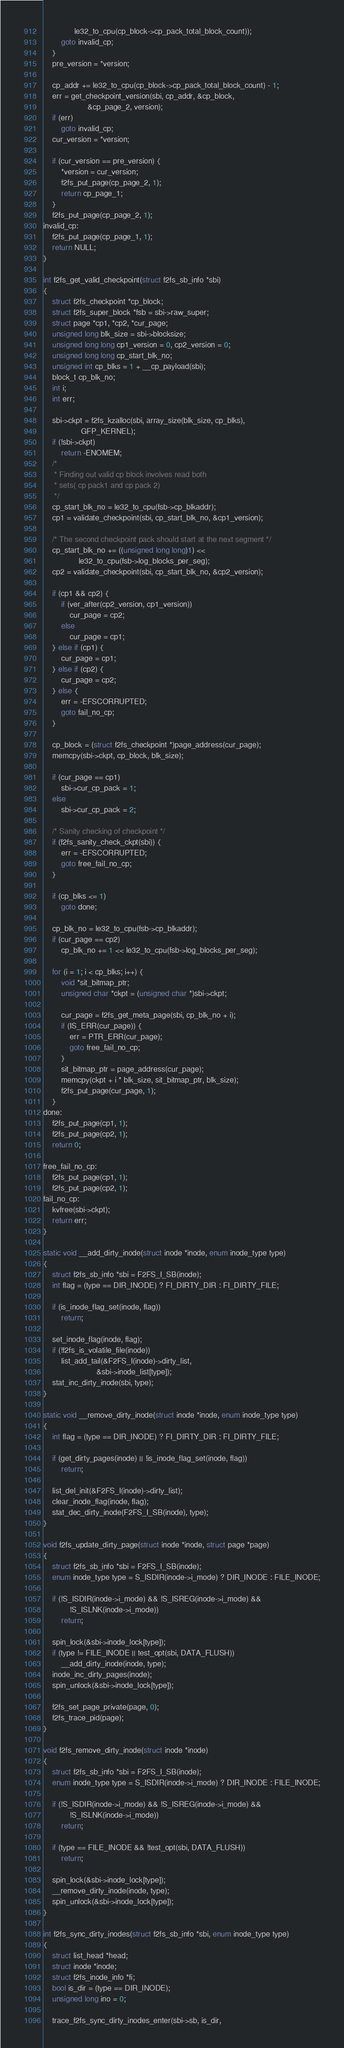<code> <loc_0><loc_0><loc_500><loc_500><_C_>			  le32_to_cpu(cp_block->cp_pack_total_block_count));
		goto invalid_cp;
	}
	pre_version = *version;

	cp_addr += le32_to_cpu(cp_block->cp_pack_total_block_count) - 1;
	err = get_checkpoint_version(sbi, cp_addr, &cp_block,
					&cp_page_2, version);
	if (err)
		goto invalid_cp;
	cur_version = *version;

	if (cur_version == pre_version) {
		*version = cur_version;
		f2fs_put_page(cp_page_2, 1);
		return cp_page_1;
	}
	f2fs_put_page(cp_page_2, 1);
invalid_cp:
	f2fs_put_page(cp_page_1, 1);
	return NULL;
}

int f2fs_get_valid_checkpoint(struct f2fs_sb_info *sbi)
{
	struct f2fs_checkpoint *cp_block;
	struct f2fs_super_block *fsb = sbi->raw_super;
	struct page *cp1, *cp2, *cur_page;
	unsigned long blk_size = sbi->blocksize;
	unsigned long long cp1_version = 0, cp2_version = 0;
	unsigned long long cp_start_blk_no;
	unsigned int cp_blks = 1 + __cp_payload(sbi);
	block_t cp_blk_no;
	int i;
	int err;

	sbi->ckpt = f2fs_kzalloc(sbi, array_size(blk_size, cp_blks),
				 GFP_KERNEL);
	if (!sbi->ckpt)
		return -ENOMEM;
	/*
	 * Finding out valid cp block involves read both
	 * sets( cp pack1 and cp pack 2)
	 */
	cp_start_blk_no = le32_to_cpu(fsb->cp_blkaddr);
	cp1 = validate_checkpoint(sbi, cp_start_blk_no, &cp1_version);

	/* The second checkpoint pack should start at the next segment */
	cp_start_blk_no += ((unsigned long long)1) <<
				le32_to_cpu(fsb->log_blocks_per_seg);
	cp2 = validate_checkpoint(sbi, cp_start_blk_no, &cp2_version);

	if (cp1 && cp2) {
		if (ver_after(cp2_version, cp1_version))
			cur_page = cp2;
		else
			cur_page = cp1;
	} else if (cp1) {
		cur_page = cp1;
	} else if (cp2) {
		cur_page = cp2;
	} else {
		err = -EFSCORRUPTED;
		goto fail_no_cp;
	}

	cp_block = (struct f2fs_checkpoint *)page_address(cur_page);
	memcpy(sbi->ckpt, cp_block, blk_size);

	if (cur_page == cp1)
		sbi->cur_cp_pack = 1;
	else
		sbi->cur_cp_pack = 2;

	/* Sanity checking of checkpoint */
	if (f2fs_sanity_check_ckpt(sbi)) {
		err = -EFSCORRUPTED;
		goto free_fail_no_cp;
	}

	if (cp_blks <= 1)
		goto done;

	cp_blk_no = le32_to_cpu(fsb->cp_blkaddr);
	if (cur_page == cp2)
		cp_blk_no += 1 << le32_to_cpu(fsb->log_blocks_per_seg);

	for (i = 1; i < cp_blks; i++) {
		void *sit_bitmap_ptr;
		unsigned char *ckpt = (unsigned char *)sbi->ckpt;

		cur_page = f2fs_get_meta_page(sbi, cp_blk_no + i);
		if (IS_ERR(cur_page)) {
			err = PTR_ERR(cur_page);
			goto free_fail_no_cp;
		}
		sit_bitmap_ptr = page_address(cur_page);
		memcpy(ckpt + i * blk_size, sit_bitmap_ptr, blk_size);
		f2fs_put_page(cur_page, 1);
	}
done:
	f2fs_put_page(cp1, 1);
	f2fs_put_page(cp2, 1);
	return 0;

free_fail_no_cp:
	f2fs_put_page(cp1, 1);
	f2fs_put_page(cp2, 1);
fail_no_cp:
	kvfree(sbi->ckpt);
	return err;
}

static void __add_dirty_inode(struct inode *inode, enum inode_type type)
{
	struct f2fs_sb_info *sbi = F2FS_I_SB(inode);
	int flag = (type == DIR_INODE) ? FI_DIRTY_DIR : FI_DIRTY_FILE;

	if (is_inode_flag_set(inode, flag))
		return;

	set_inode_flag(inode, flag);
	if (!f2fs_is_volatile_file(inode))
		list_add_tail(&F2FS_I(inode)->dirty_list,
						&sbi->inode_list[type]);
	stat_inc_dirty_inode(sbi, type);
}

static void __remove_dirty_inode(struct inode *inode, enum inode_type type)
{
	int flag = (type == DIR_INODE) ? FI_DIRTY_DIR : FI_DIRTY_FILE;

	if (get_dirty_pages(inode) || !is_inode_flag_set(inode, flag))
		return;

	list_del_init(&F2FS_I(inode)->dirty_list);
	clear_inode_flag(inode, flag);
	stat_dec_dirty_inode(F2FS_I_SB(inode), type);
}

void f2fs_update_dirty_page(struct inode *inode, struct page *page)
{
	struct f2fs_sb_info *sbi = F2FS_I_SB(inode);
	enum inode_type type = S_ISDIR(inode->i_mode) ? DIR_INODE : FILE_INODE;

	if (!S_ISDIR(inode->i_mode) && !S_ISREG(inode->i_mode) &&
			!S_ISLNK(inode->i_mode))
		return;

	spin_lock(&sbi->inode_lock[type]);
	if (type != FILE_INODE || test_opt(sbi, DATA_FLUSH))
		__add_dirty_inode(inode, type);
	inode_inc_dirty_pages(inode);
	spin_unlock(&sbi->inode_lock[type]);

	f2fs_set_page_private(page, 0);
	f2fs_trace_pid(page);
}

void f2fs_remove_dirty_inode(struct inode *inode)
{
	struct f2fs_sb_info *sbi = F2FS_I_SB(inode);
	enum inode_type type = S_ISDIR(inode->i_mode) ? DIR_INODE : FILE_INODE;

	if (!S_ISDIR(inode->i_mode) && !S_ISREG(inode->i_mode) &&
			!S_ISLNK(inode->i_mode))
		return;

	if (type == FILE_INODE && !test_opt(sbi, DATA_FLUSH))
		return;

	spin_lock(&sbi->inode_lock[type]);
	__remove_dirty_inode(inode, type);
	spin_unlock(&sbi->inode_lock[type]);
}

int f2fs_sync_dirty_inodes(struct f2fs_sb_info *sbi, enum inode_type type)
{
	struct list_head *head;
	struct inode *inode;
	struct f2fs_inode_info *fi;
	bool is_dir = (type == DIR_INODE);
	unsigned long ino = 0;

	trace_f2fs_sync_dirty_inodes_enter(sbi->sb, is_dir,</code> 